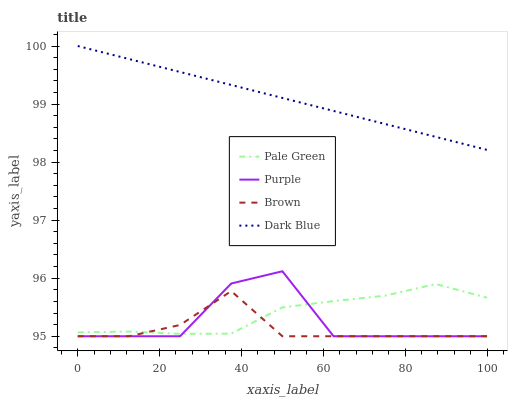Does Brown have the minimum area under the curve?
Answer yes or no. Yes. Does Dark Blue have the maximum area under the curve?
Answer yes or no. Yes. Does Pale Green have the minimum area under the curve?
Answer yes or no. No. Does Pale Green have the maximum area under the curve?
Answer yes or no. No. Is Dark Blue the smoothest?
Answer yes or no. Yes. Is Purple the roughest?
Answer yes or no. Yes. Is Brown the smoothest?
Answer yes or no. No. Is Brown the roughest?
Answer yes or no. No. Does Purple have the lowest value?
Answer yes or no. Yes. Does Pale Green have the lowest value?
Answer yes or no. No. Does Dark Blue have the highest value?
Answer yes or no. Yes. Does Pale Green have the highest value?
Answer yes or no. No. Is Purple less than Dark Blue?
Answer yes or no. Yes. Is Dark Blue greater than Brown?
Answer yes or no. Yes. Does Pale Green intersect Purple?
Answer yes or no. Yes. Is Pale Green less than Purple?
Answer yes or no. No. Is Pale Green greater than Purple?
Answer yes or no. No. Does Purple intersect Dark Blue?
Answer yes or no. No. 